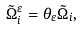<formula> <loc_0><loc_0><loc_500><loc_500>\tilde { \Omega } _ { i } ^ { \varepsilon } = \theta _ { \varepsilon } \tilde { \Omega } _ { i } ,</formula> 